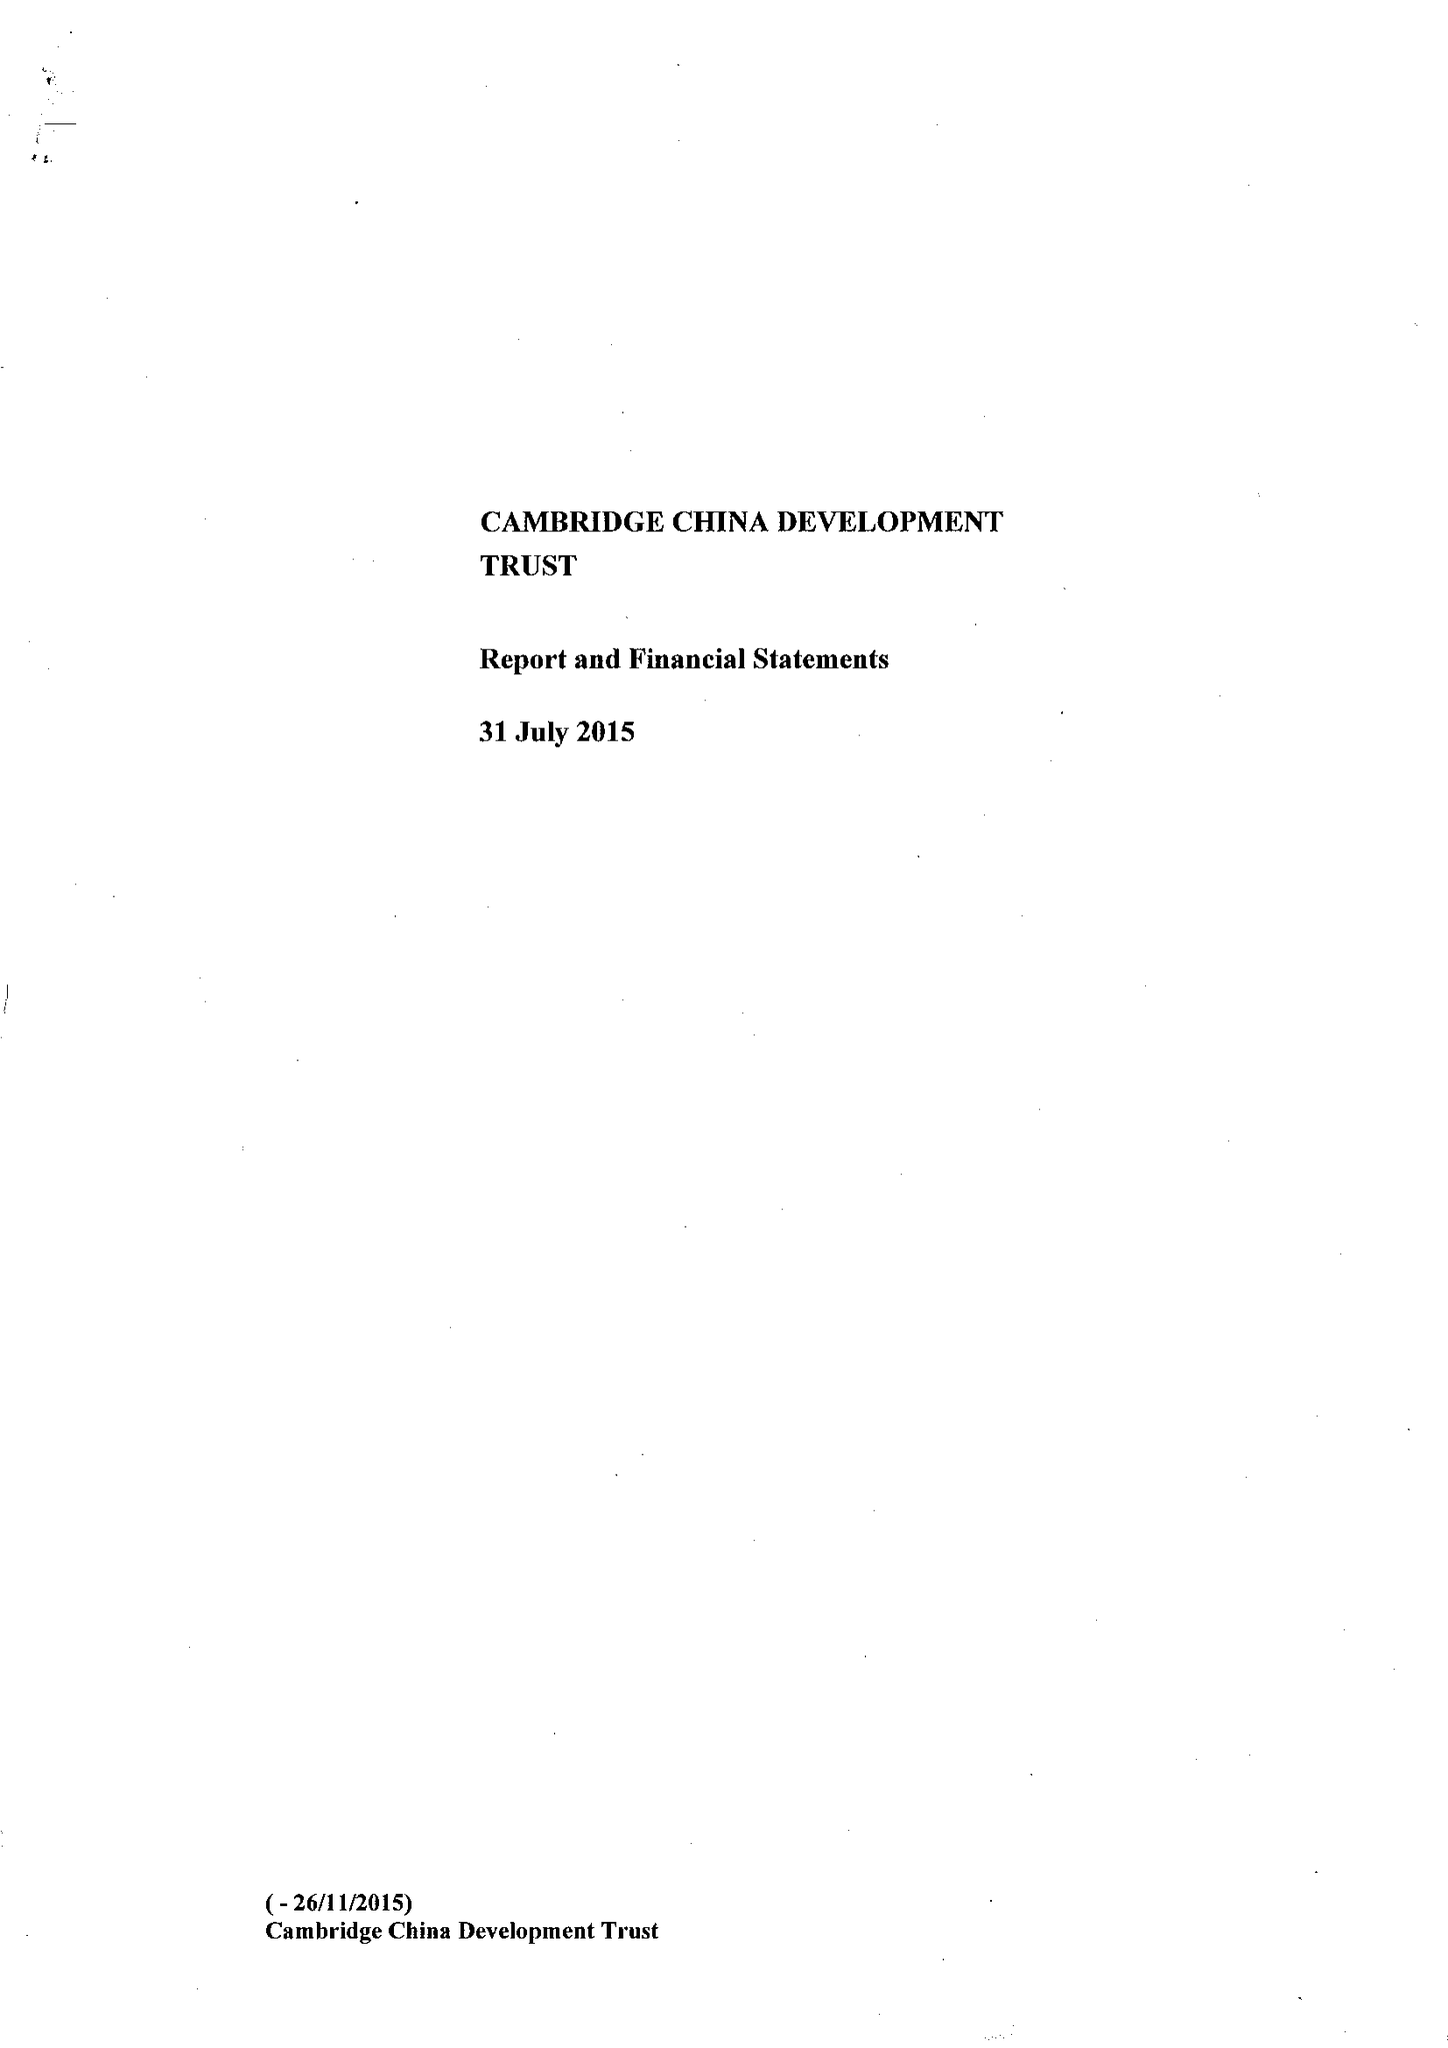What is the value for the address__post_town?
Answer the question using a single word or phrase. CAMBRIDGE 